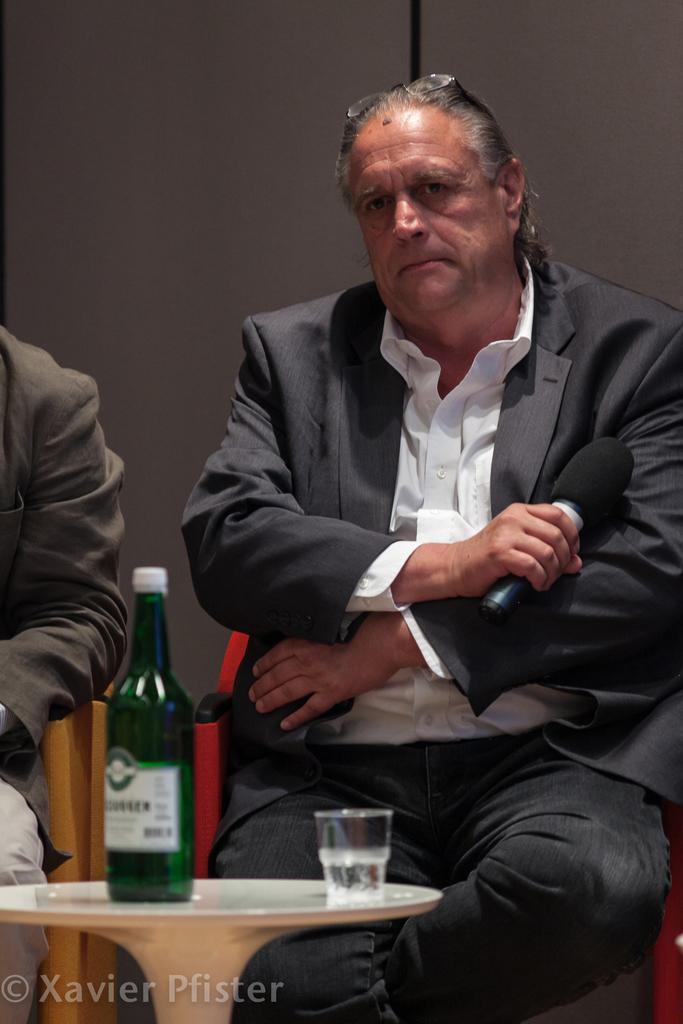Can you describe this image briefly? In the foreground of the picture there is a desk, on the desk there is a bottle and glass. In the center of the picture there are two men sitting in chairs. In the background it is wall painted white. 